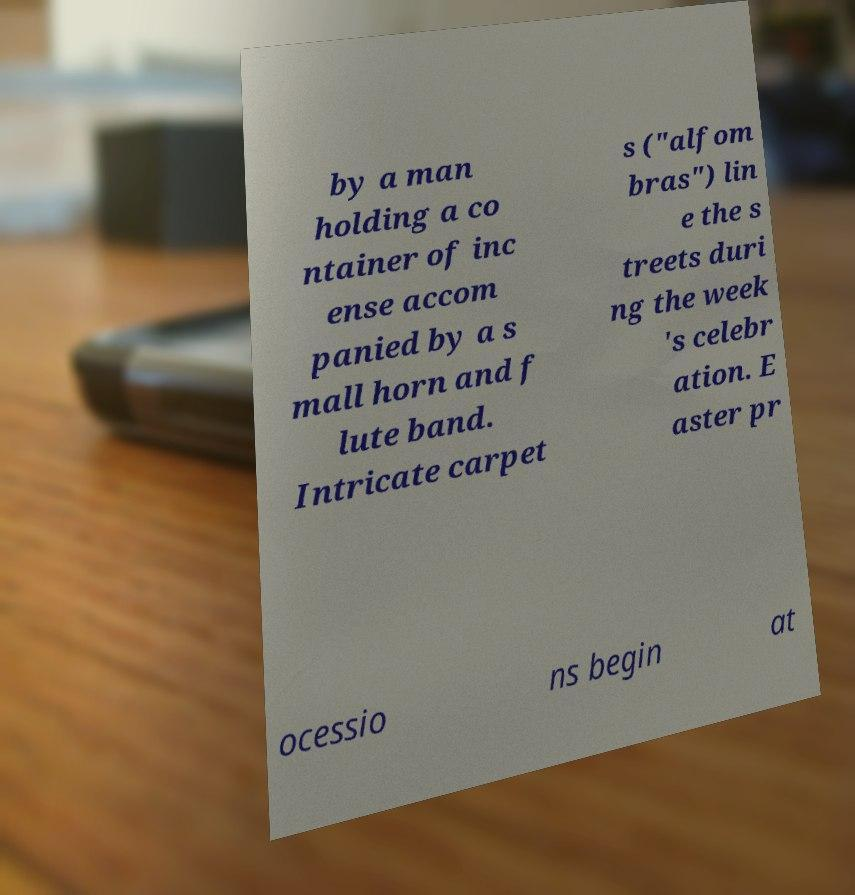Please read and relay the text visible in this image. What does it say? by a man holding a co ntainer of inc ense accom panied by a s mall horn and f lute band. Intricate carpet s ("alfom bras") lin e the s treets duri ng the week 's celebr ation. E aster pr ocessio ns begin at 